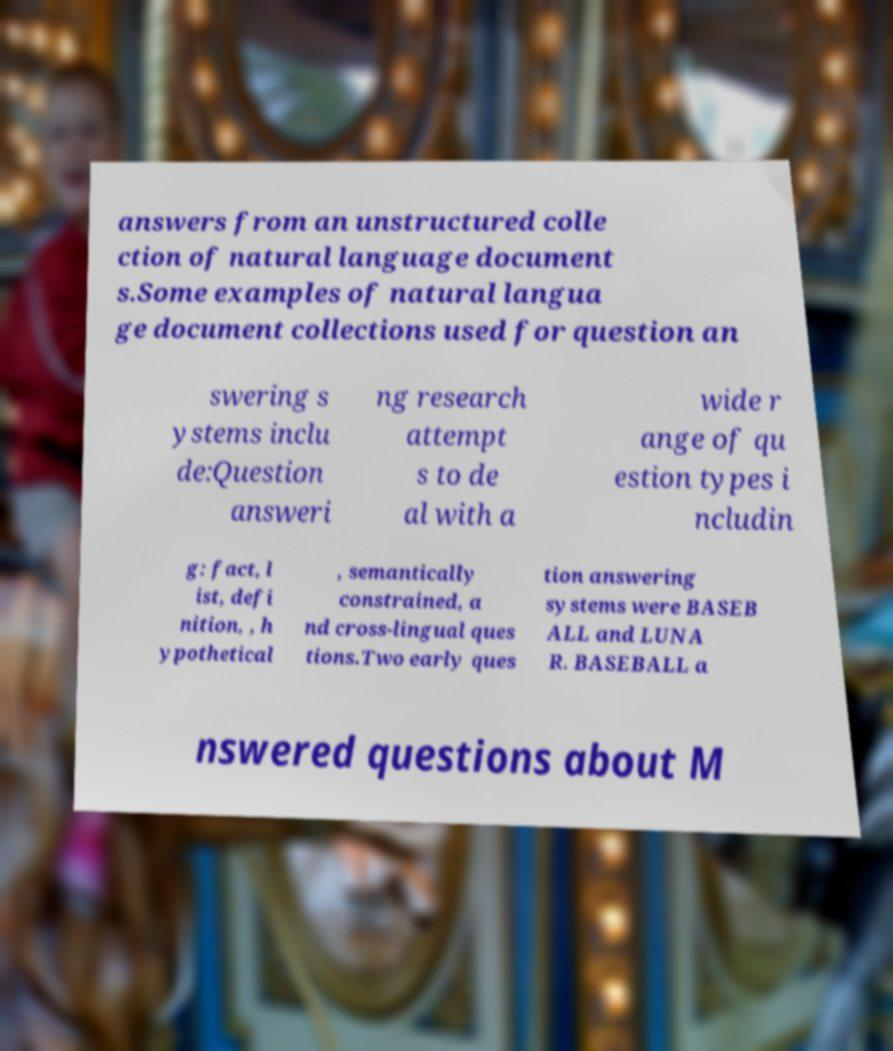Can you accurately transcribe the text from the provided image for me? answers from an unstructured colle ction of natural language document s.Some examples of natural langua ge document collections used for question an swering s ystems inclu de:Question answeri ng research attempt s to de al with a wide r ange of qu estion types i ncludin g: fact, l ist, defi nition, , h ypothetical , semantically constrained, a nd cross-lingual ques tions.Two early ques tion answering systems were BASEB ALL and LUNA R. BASEBALL a nswered questions about M 